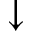<formula> <loc_0><loc_0><loc_500><loc_500>\downarrow</formula> 